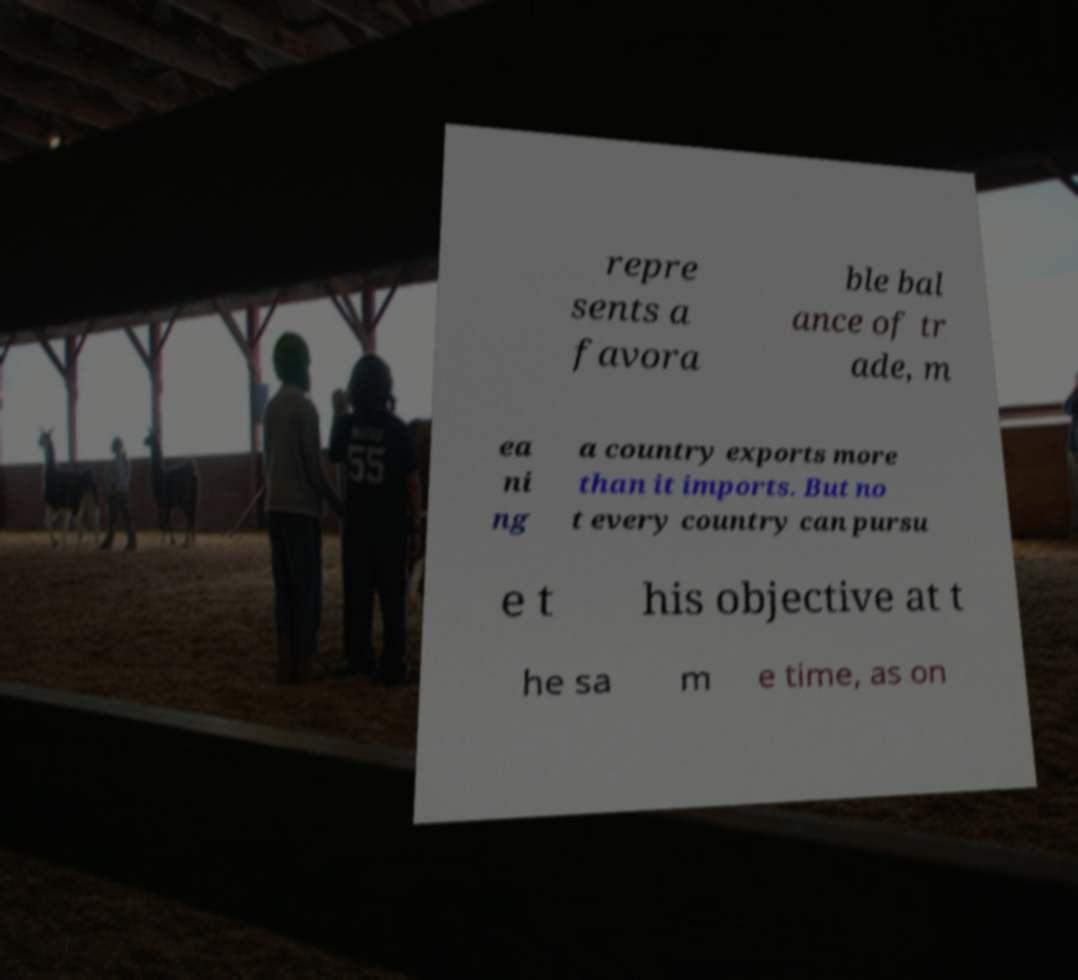Could you assist in decoding the text presented in this image and type it out clearly? repre sents a favora ble bal ance of tr ade, m ea ni ng a country exports more than it imports. But no t every country can pursu e t his objective at t he sa m e time, as on 